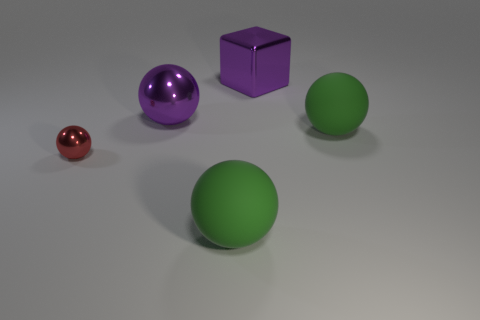There is a object that is the same color as the block; what is its shape?
Your response must be concise. Sphere. The purple thing that is the same size as the purple sphere is what shape?
Keep it short and to the point. Cube. What material is the thing that is the same color as the metal block?
Provide a succinct answer. Metal. There is a large purple metallic cube; are there any large green matte things right of it?
Ensure brevity in your answer.  Yes. Is there another shiny object of the same shape as the red thing?
Keep it short and to the point. Yes. Is the shape of the large purple thing behind the purple ball the same as the large green matte object in front of the red metallic thing?
Provide a short and direct response. No. Is there a object that has the same size as the purple sphere?
Make the answer very short. Yes. Are there an equal number of matte things behind the large metallic ball and green rubber spheres in front of the small red thing?
Offer a terse response. No. Does the object in front of the red ball have the same material as the big green object that is right of the large shiny block?
Offer a terse response. Yes. How many other objects are the same color as the small sphere?
Your answer should be compact. 0. 